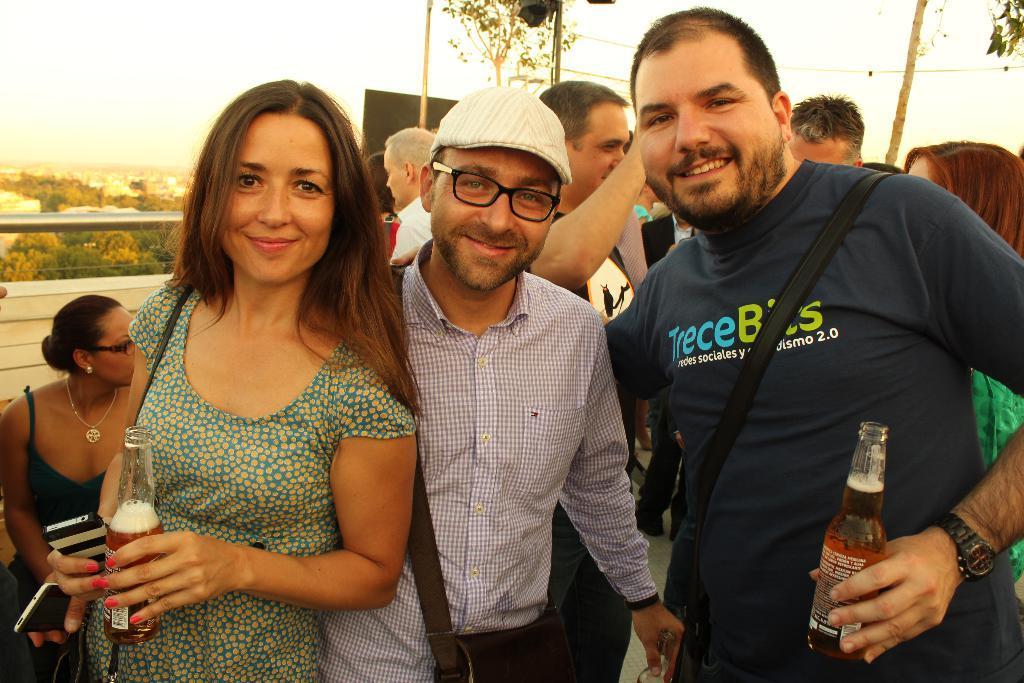Please provide a concise description of this image. In this image I can see the group of people standing. Among them one person is wearing the hat and two of them are holding the bottle. Backside of them there is a sky and the trees. 